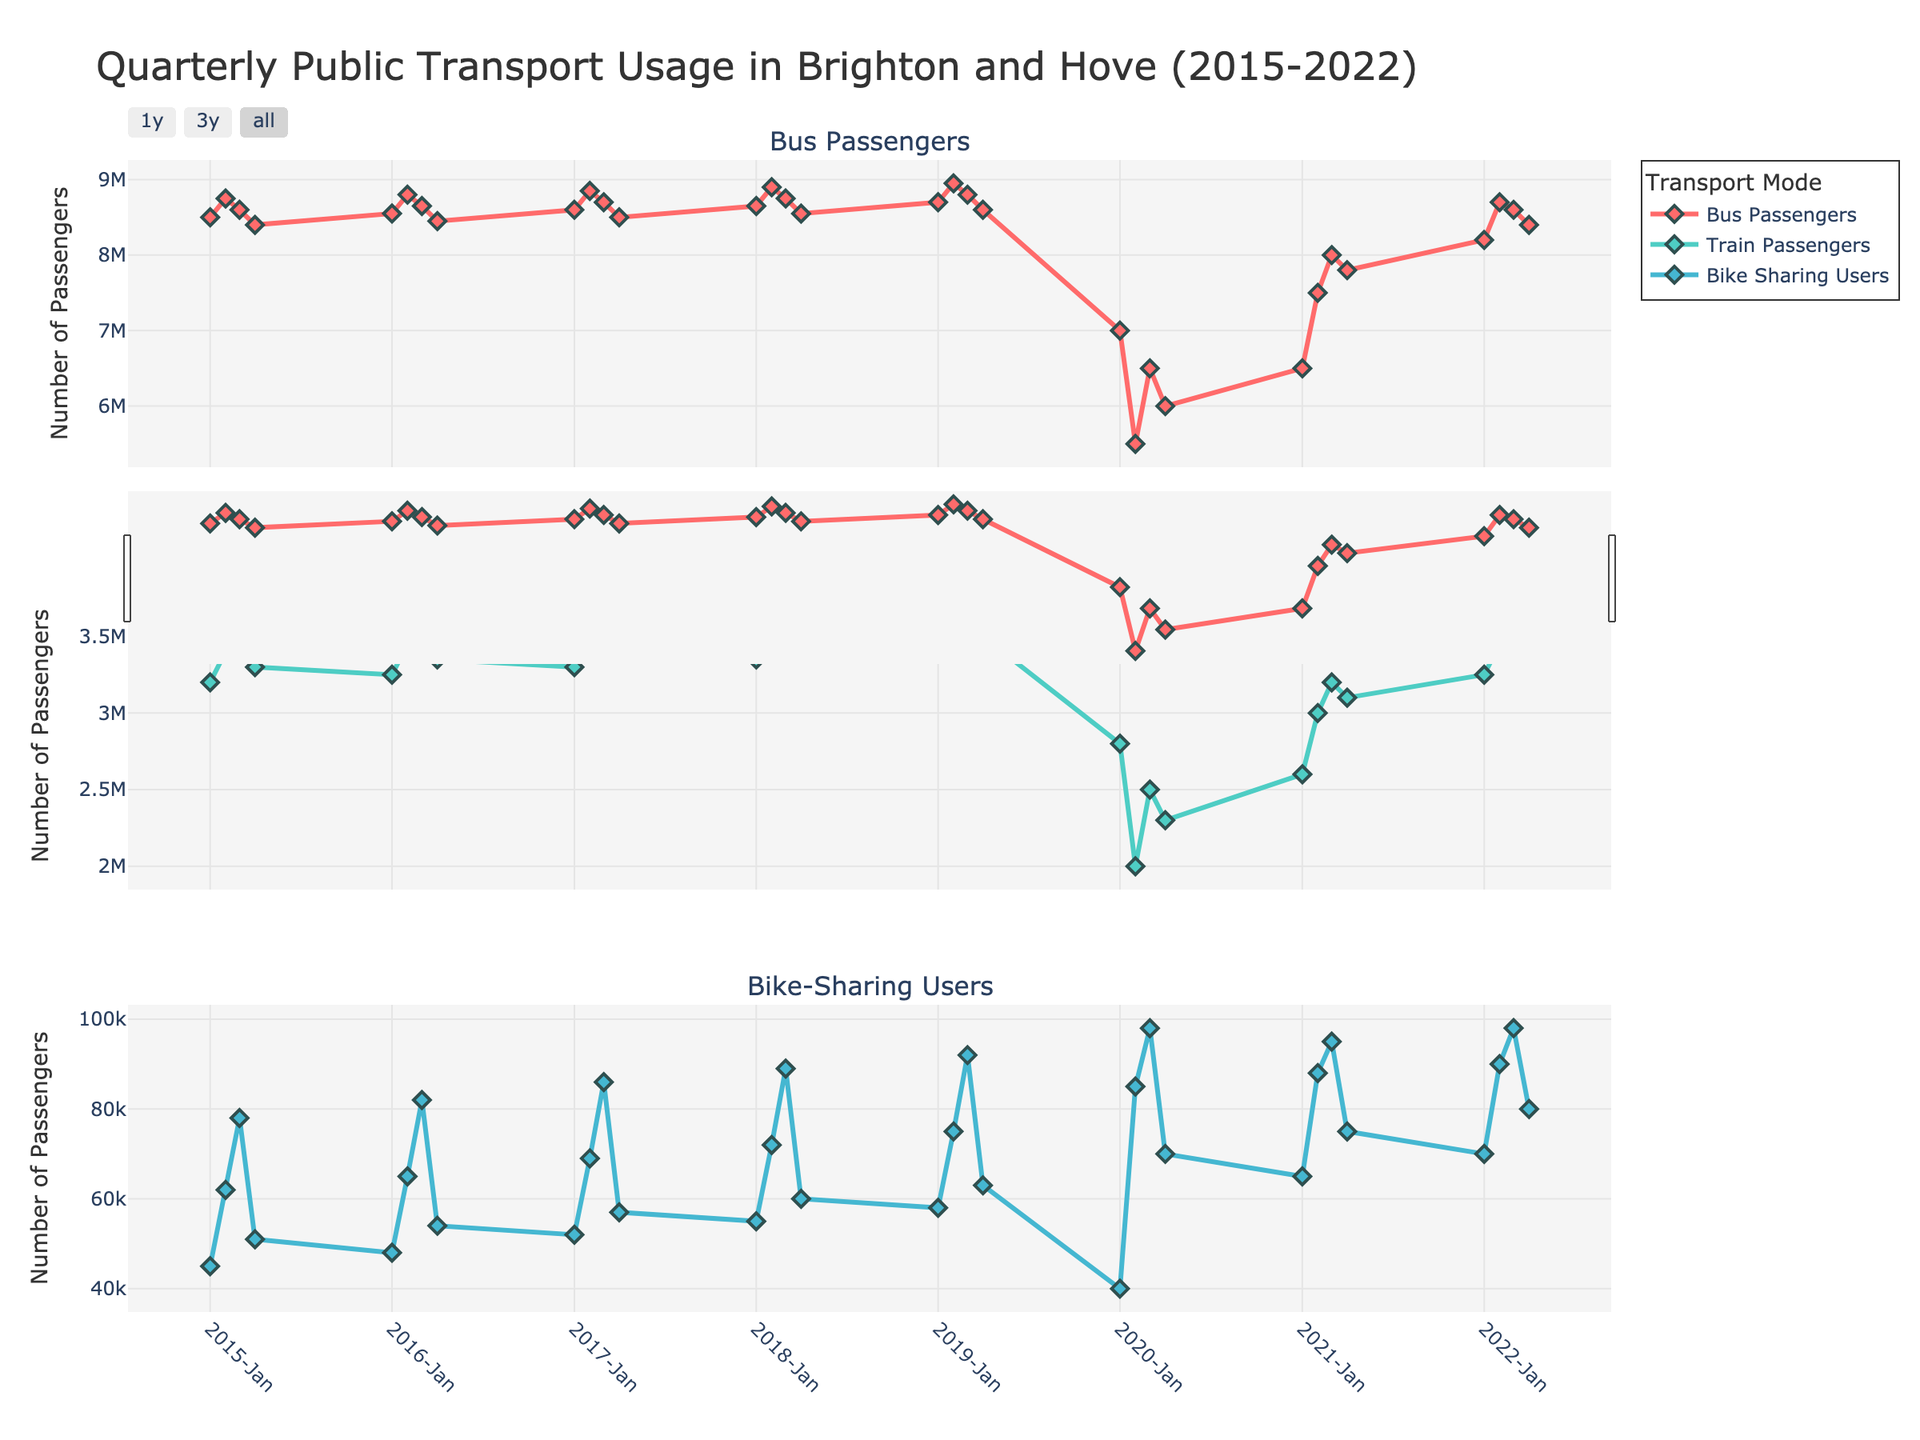What is the title of the figure? The title is usually located at the top of the figure. Here, it reads "Quarterly Public Transport Usage in Brighton and Hove (2015-2022)."
Answer: Quarterly Public Transport Usage in Brighton and Hove (2015-2022) What transportation mode had the highest number of users in Q3 2020? By looking at the third quarter (Q3) of 2020 in each subplot, we see that Bike-Sharing Users had the highest value with 98,000 users.
Answer: Bike-Sharing Users How did the number of bus passengers change from Q4 2019 to Q1 2020? We need to compare the number of bus passengers in Q4 2019 and Q1 2020. In Q4 2019, there were 8.6 million bus passengers, and it dropped to 7 million in Q1 2020. So, the number of bus passengers decreased by 1.6 million.
Answer: Decreased by 1.6 million Which quarter saw the highest train passenger count in 2022? In each subplot for 2022, we compare the train passenger counts for each quarter. Q3 2022 had the highest count with 3.55 million passengers.
Answer: Q3 2022 What was the trend in bike-sharing users from 2015 to 2022? By observing the third subplot from 2015 to 2022, we see that the number of bike-sharing users initially increased, then had fluctuations, and dramatically increased again after the dip in 2020, ending with a higher number in 2022 compared to 2015.
Answer: Increasing trend with fluctuations Compare the number of train passengers and bike-sharing users in Q2 2021. Which had more users, and by how much? In Q2 2021, the train had 3 million passengers, and bike-sharing had 88,000 users. The difference between them is 2.912 million more train passengers than bike-sharing users.
Answer: Train passengers by 2.912 million What was the lowest point for bus passengers in the provided period? By scanning the bus passenger subplot, we identify the lowest point at Q2 2020 with 5.5 million passengers.
Answer: Q2 2020 What's the average number of train passengers for the year 2016? We sum the train passengers for each quarter in 2016: 3.25M + 3.45M + 3.55M + 3.35M equals 13.6 million. To find the average, divide 13.6M by 4, which equals 3.4 million.
Answer: 3.4 million What is the typical range slider used for in the chart? The range slider is typically used to zoom into specific date ranges on the x-axis to observe trends and details more closely in specific time periods.
Answer: To zoom into specific date ranges 